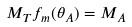Convert formula to latex. <formula><loc_0><loc_0><loc_500><loc_500>M _ { T } f _ { m } ( \theta _ { A } ) = M _ { A }</formula> 